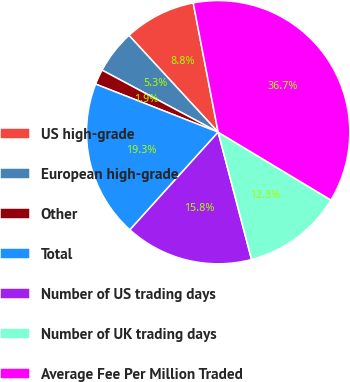Convert chart to OTSL. <chart><loc_0><loc_0><loc_500><loc_500><pie_chart><fcel>US high-grade<fcel>European high-grade<fcel>Other<fcel>Total<fcel>Number of US trading days<fcel>Number of UK trading days<fcel>Average Fee Per Million Traded<nl><fcel>8.82%<fcel>5.34%<fcel>1.86%<fcel>19.26%<fcel>15.78%<fcel>12.3%<fcel>36.66%<nl></chart> 